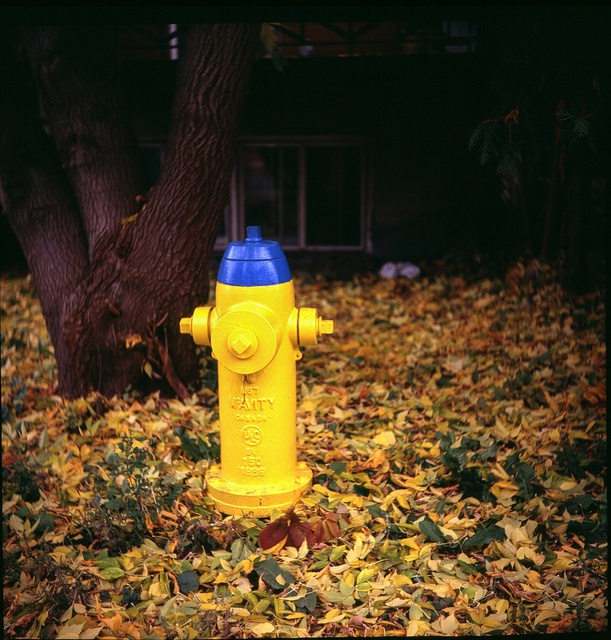Describe the objects in this image and their specific colors. I can see a fire hydrant in black, gold, orange, yellow, and olive tones in this image. 